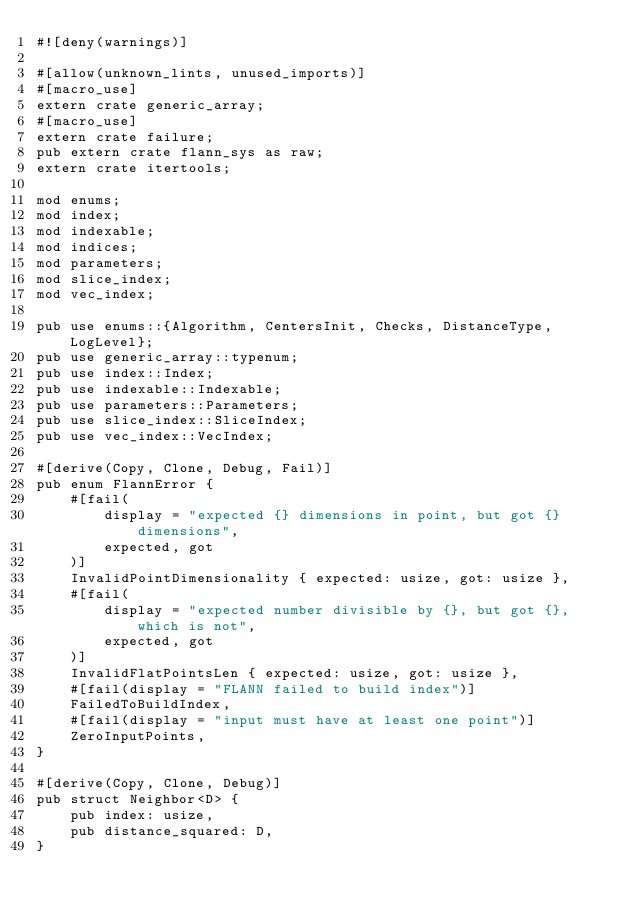<code> <loc_0><loc_0><loc_500><loc_500><_Rust_>#![deny(warnings)]

#[allow(unknown_lints, unused_imports)]
#[macro_use]
extern crate generic_array;
#[macro_use]
extern crate failure;
pub extern crate flann_sys as raw;
extern crate itertools;

mod enums;
mod index;
mod indexable;
mod indices;
mod parameters;
mod slice_index;
mod vec_index;

pub use enums::{Algorithm, CentersInit, Checks, DistanceType, LogLevel};
pub use generic_array::typenum;
pub use index::Index;
pub use indexable::Indexable;
pub use parameters::Parameters;
pub use slice_index::SliceIndex;
pub use vec_index::VecIndex;

#[derive(Copy, Clone, Debug, Fail)]
pub enum FlannError {
    #[fail(
        display = "expected {} dimensions in point, but got {} dimensions",
        expected, got
    )]
    InvalidPointDimensionality { expected: usize, got: usize },
    #[fail(
        display = "expected number divisible by {}, but got {}, which is not",
        expected, got
    )]
    InvalidFlatPointsLen { expected: usize, got: usize },
    #[fail(display = "FLANN failed to build index")]
    FailedToBuildIndex,
    #[fail(display = "input must have at least one point")]
    ZeroInputPoints,
}

#[derive(Copy, Clone, Debug)]
pub struct Neighbor<D> {
    pub index: usize,
    pub distance_squared: D,
}
</code> 